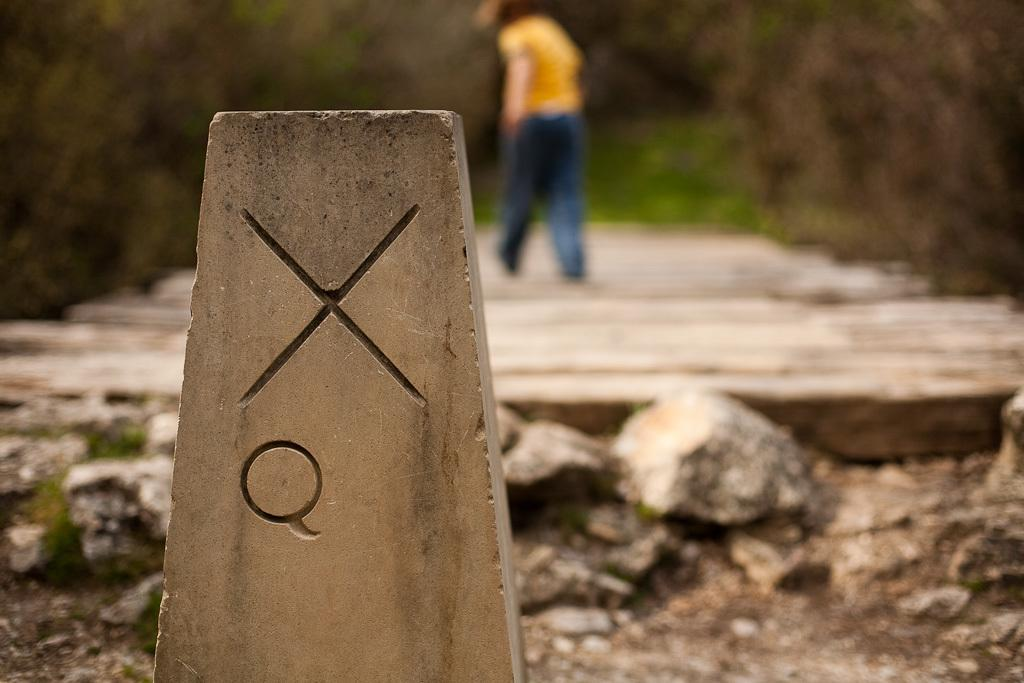What symbol can be seen on the stone in the image? There is an X symbol on a stone in the image. How would you describe the overall clarity of the image? The background of the image is blurry. What type of natural environment is visible in the background? There are trees visible in the background. Can you identify any human presence in the image? Yes, there is a person in the image. What type of camera is the person using to take a picture of the cart in the image? There is no camera, person, or cart present in the image. 